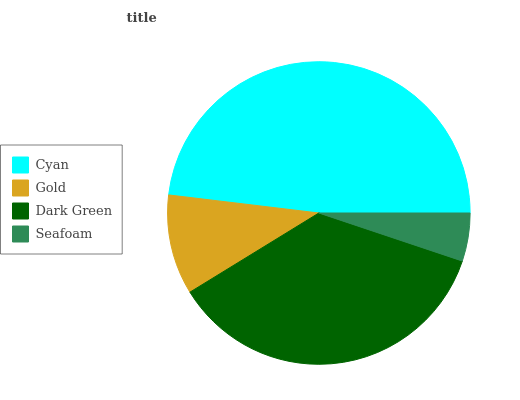Is Seafoam the minimum?
Answer yes or no. Yes. Is Cyan the maximum?
Answer yes or no. Yes. Is Gold the minimum?
Answer yes or no. No. Is Gold the maximum?
Answer yes or no. No. Is Cyan greater than Gold?
Answer yes or no. Yes. Is Gold less than Cyan?
Answer yes or no. Yes. Is Gold greater than Cyan?
Answer yes or no. No. Is Cyan less than Gold?
Answer yes or no. No. Is Dark Green the high median?
Answer yes or no. Yes. Is Gold the low median?
Answer yes or no. Yes. Is Seafoam the high median?
Answer yes or no. No. Is Seafoam the low median?
Answer yes or no. No. 